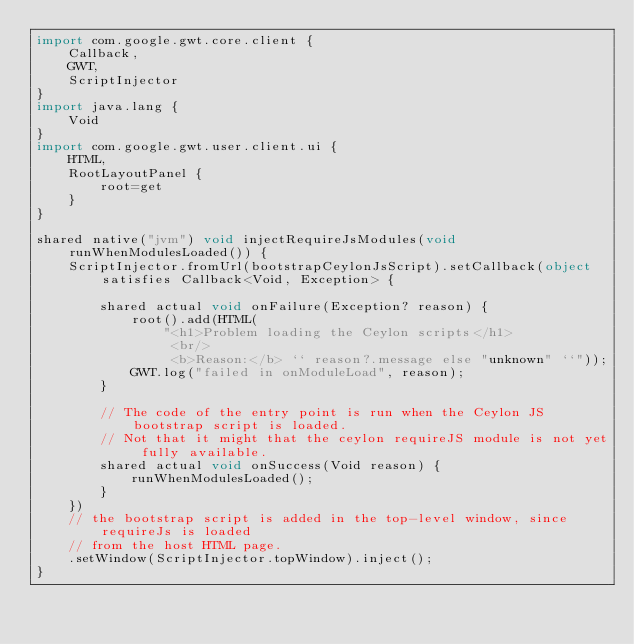Convert code to text. <code><loc_0><loc_0><loc_500><loc_500><_Ceylon_>import com.google.gwt.core.client {
    Callback,
    GWT,
    ScriptInjector
}
import java.lang {
    Void
}
import com.google.gwt.user.client.ui {
    HTML,
    RootLayoutPanel {
        root=get
    }
}

shared native("jvm") void injectRequireJsModules(void runWhenModulesLoaded()) {
    ScriptInjector.fromUrl(bootstrapCeylonJsScript).setCallback(object satisfies Callback<Void, Exception> {
        
        shared actual void onFailure(Exception? reason) {
            root().add(HTML(
                "<h1>Problem loading the Ceylon scripts</h1>
                 <br/>
                 <b>Reason:</b> `` reason?.message else "unknown" ``"));
            GWT.log("failed in onModuleLoad", reason);
        }
        
        // The code of the entry point is run when the Ceylon JS bootstrap script is loaded.
        // Not that it might that the ceylon requireJS module is not yet fully available.
        shared actual void onSuccess(Void reason) {
            runWhenModulesLoaded();
        }
    })
    // the bootstrap script is added in the top-level window, since requireJs is loaded
    // from the host HTML page.
    .setWindow(ScriptInjector.topWindow).inject();
}
</code> 